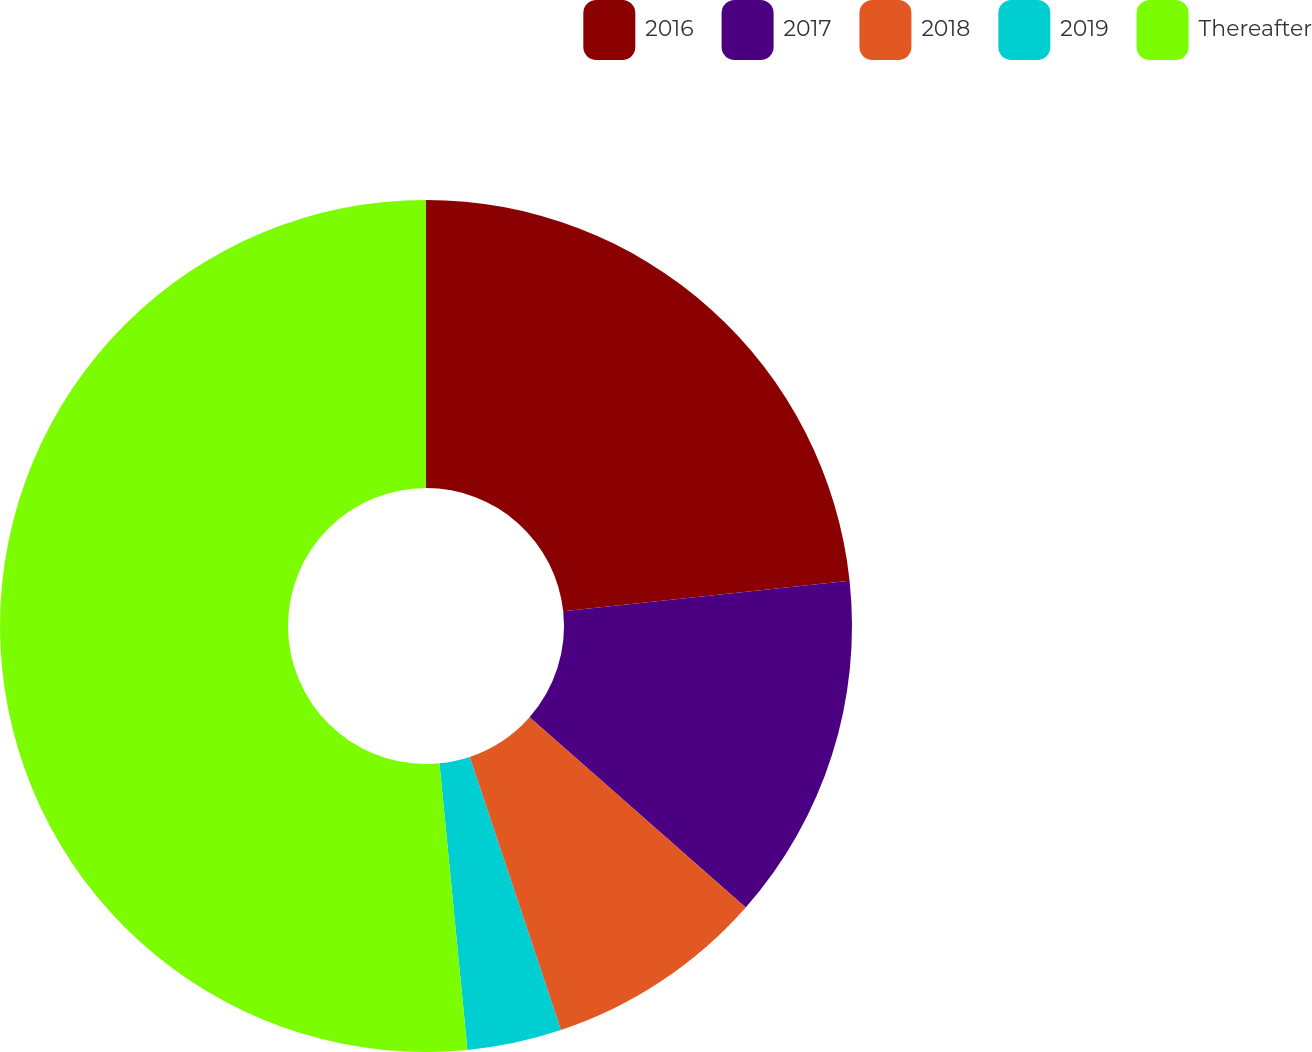Convert chart. <chart><loc_0><loc_0><loc_500><loc_500><pie_chart><fcel>2016<fcel>2017<fcel>2018<fcel>2019<fcel>Thereafter<nl><fcel>23.31%<fcel>13.18%<fcel>8.38%<fcel>3.58%<fcel>51.55%<nl></chart> 